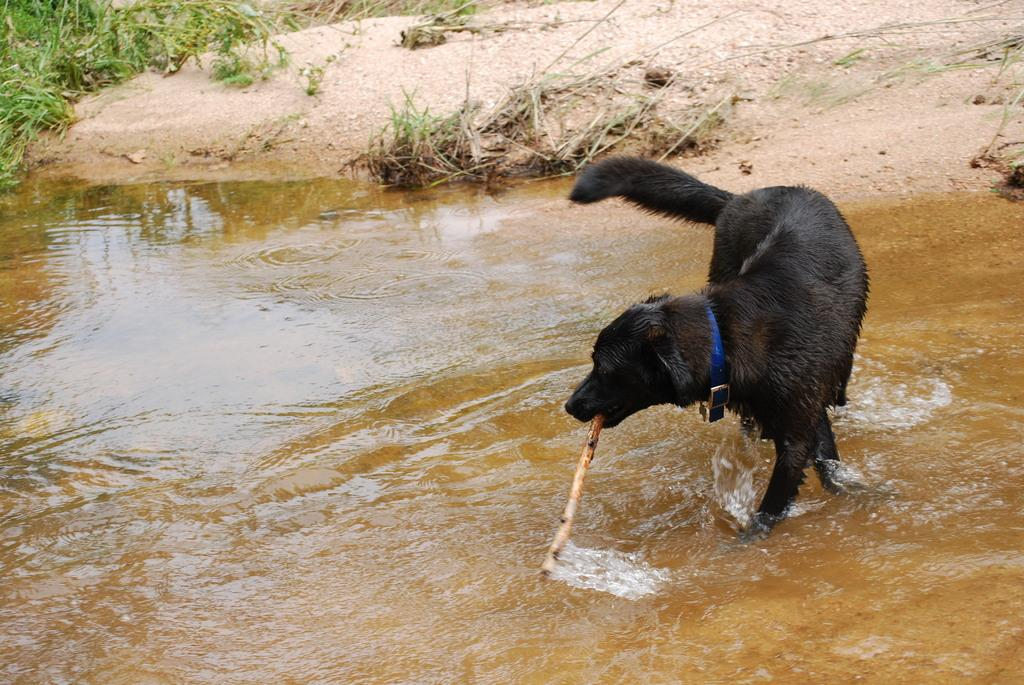What animal can be seen in the picture? There is a dog in the picture. What is the dog holding in its mouth? The dog is holding a wooden stick in its mouth. What is visible on the ground in the image? There is water visible on the ground. What type of terrain is visible in the background of the image? There is sand and plants in the background of the image. Can you tell me what type of stamp is on the dog's paw in the image? There is no stamp visible on the dog's paw in the image. Is the dog swimming in the water in the image? The image does not show the dog swimming; it is holding a wooden stick in its mouth and standing on the ground. 